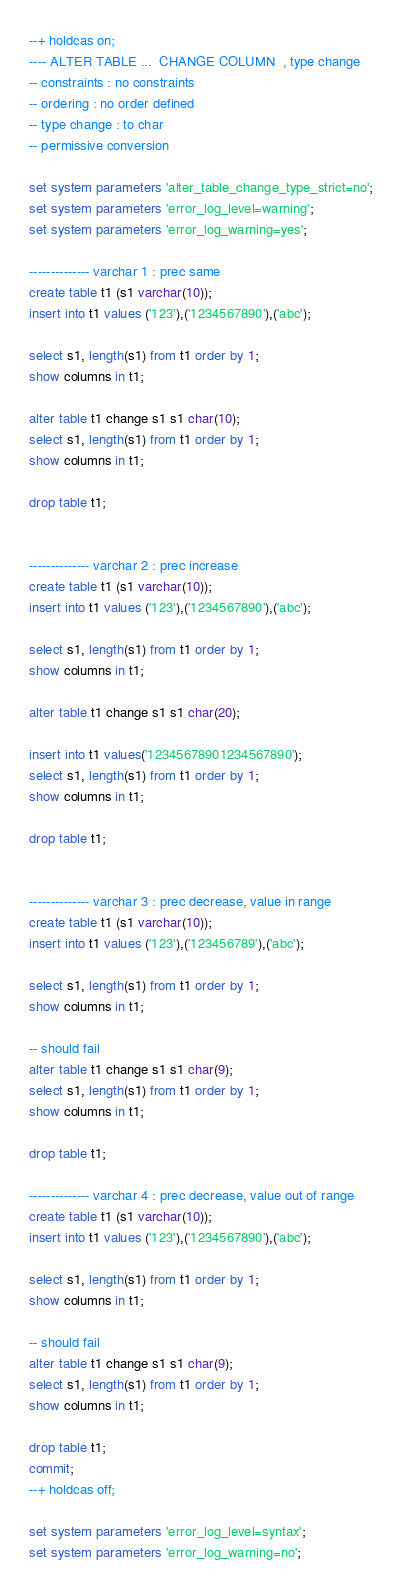<code> <loc_0><loc_0><loc_500><loc_500><_SQL_>--+ holdcas on;
---- ALTER TABLE ...  CHANGE COLUMN  , type change
-- constraints : no constraints
-- ordering : no order defined
-- type change : to char
-- permissive conversion

set system parameters 'alter_table_change_type_strict=no';
set system parameters 'error_log_level=warning';
set system parameters 'error_log_warning=yes';

-------------- varchar 1 : prec same
create table t1 (s1 varchar(10));
insert into t1 values ('123'),('1234567890'),('abc');

select s1, length(s1) from t1 order by 1;
show columns in t1;

alter table t1 change s1 s1 char(10);
select s1, length(s1) from t1 order by 1;
show columns in t1;

drop table t1;


-------------- varchar 2 : prec increase 
create table t1 (s1 varchar(10));
insert into t1 values ('123'),('1234567890'),('abc');

select s1, length(s1) from t1 order by 1;
show columns in t1;

alter table t1 change s1 s1 char(20);

insert into t1 values('12345678901234567890');
select s1, length(s1) from t1 order by 1;
show columns in t1;

drop table t1;


-------------- varchar 3 : prec decrease, value in range
create table t1 (s1 varchar(10));
insert into t1 values ('123'),('123456789'),('abc');

select s1, length(s1) from t1 order by 1; 
show columns in t1;

-- should fail
alter table t1 change s1 s1 char(9);
select s1, length(s1) from t1 order by 1;
show columns in t1;

drop table t1;

-------------- varchar 4 : prec decrease, value out of range
create table t1 (s1 varchar(10));
insert into t1 values ('123'),('1234567890'),('abc');

select s1, length(s1) from t1 order by 1; 
show columns in t1;

-- should fail
alter table t1 change s1 s1 char(9);
select s1, length(s1) from t1 order by 1;
show columns in t1;

drop table t1;
commit;
--+ holdcas off;

set system parameters 'error_log_level=syntax';
set system parameters 'error_log_warning=no';
</code> 